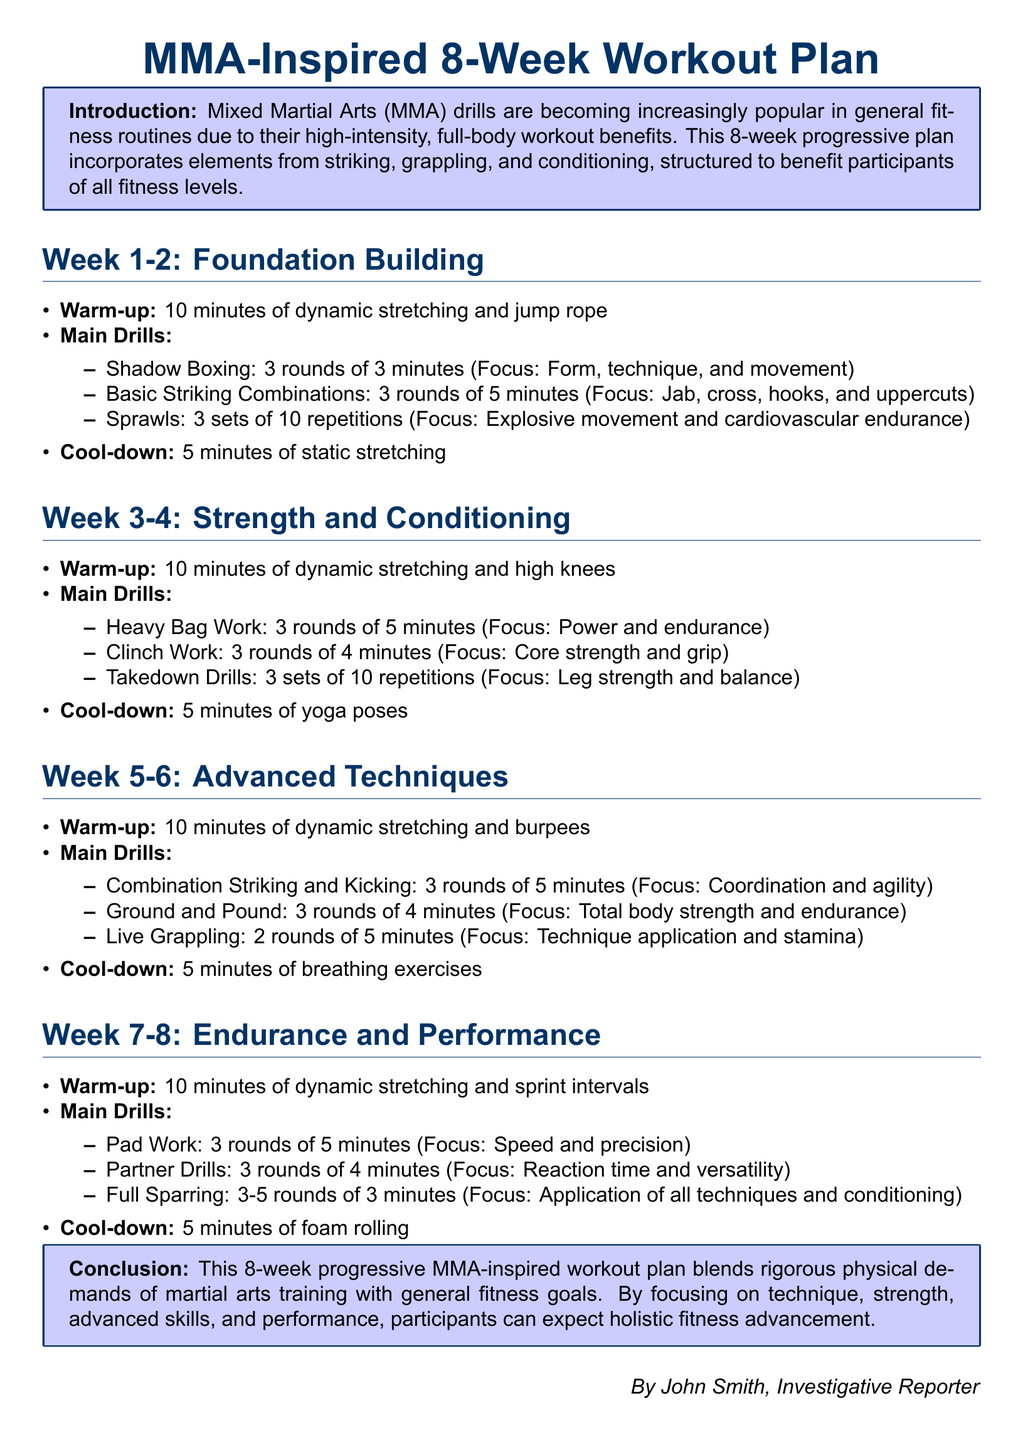What is the title of the document? The title is presented as the main heading in large font at the top of the document.
Answer: MMA-Inspired 8-Week Workout Plan How many weeks does the workout plan cover? The document explicitly states that it is an 8-week plan, organized into different phases.
Answer: 8 weeks What type of stretching is included in the warm-up for Weeks 3-4? The specific type of warm-up is listed under the Warm-up section for that particular phase.
Answer: Dynamic stretching What is the focus of the cool-down in Week 5-6? The document specifies the type of cool-down activity and its intended purpose for that week.
Answer: Breathing exercises How many rounds of Full Sparring are suggested for Weeks 7-8? The number of rounds is clearly indicated under the Main Drills section for that week.
Answer: 3-5 rounds What is emphasized in Week 1-2 during Shadow Boxing? The focus areas are outlined for each drill in the workout plan, including this one.
Answer: Form, technique, and movement What equipment is used during the Heavy Bag Work? The activity type mentioned indicates the equipment used during this exercise.
Answer: Heavy Bag In which weeks is Live Grappling included? The weeks during which this drill takes place are specified within the document content.
Answer: Weeks 5-6 